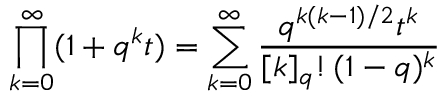<formula> <loc_0><loc_0><loc_500><loc_500>\prod _ { k = 0 } ^ { \infty } ( 1 + q ^ { k } t ) = \sum _ { k = 0 } ^ { \infty } { \frac { q ^ { k ( k - 1 ) / 2 } t ^ { k } } { [ k ] _ { q } ! \, ( 1 - q ) ^ { k } } }</formula> 